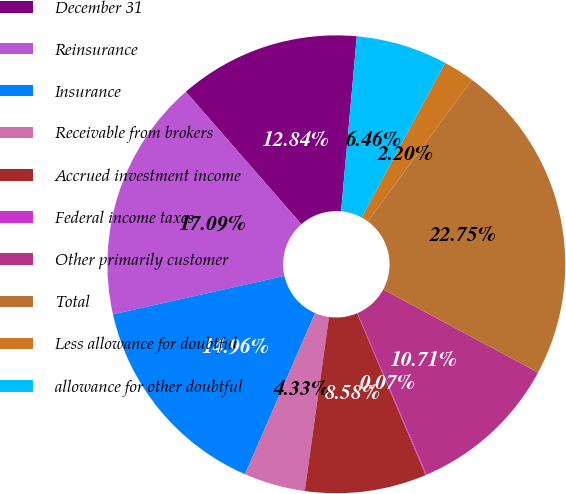Convert chart. <chart><loc_0><loc_0><loc_500><loc_500><pie_chart><fcel>December 31<fcel>Reinsurance<fcel>Insurance<fcel>Receivable from brokers<fcel>Accrued investment income<fcel>Federal income taxes<fcel>Other primarily customer<fcel>Total<fcel>Less allowance for doubtful<fcel>allowance for other doubtful<nl><fcel>12.84%<fcel>17.09%<fcel>14.96%<fcel>4.33%<fcel>8.58%<fcel>0.07%<fcel>10.71%<fcel>22.75%<fcel>2.2%<fcel>6.46%<nl></chart> 